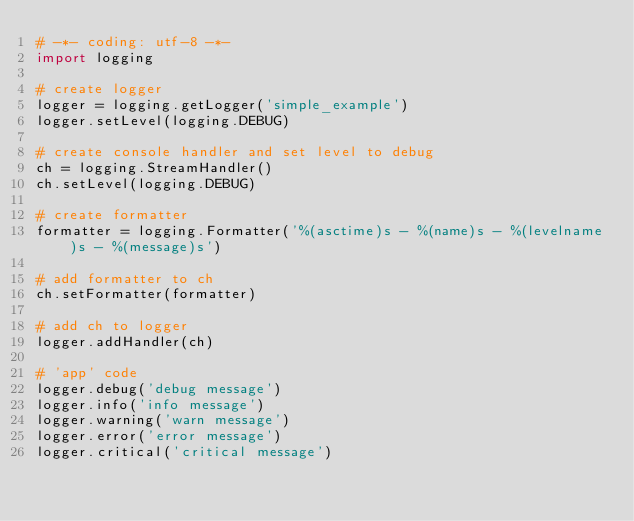Convert code to text. <code><loc_0><loc_0><loc_500><loc_500><_Python_># -*- coding: utf-8 -*-
import logging

# create logger
logger = logging.getLogger('simple_example')
logger.setLevel(logging.DEBUG)

# create console handler and set level to debug
ch = logging.StreamHandler()
ch.setLevel(logging.DEBUG)

# create formatter
formatter = logging.Formatter('%(asctime)s - %(name)s - %(levelname)s - %(message)s')

# add formatter to ch
ch.setFormatter(formatter)

# add ch to logger
logger.addHandler(ch)

# 'app' code
logger.debug('debug message')
logger.info('info message')
logger.warning('warn message')
logger.error('error message')
logger.critical('critical message')
</code> 